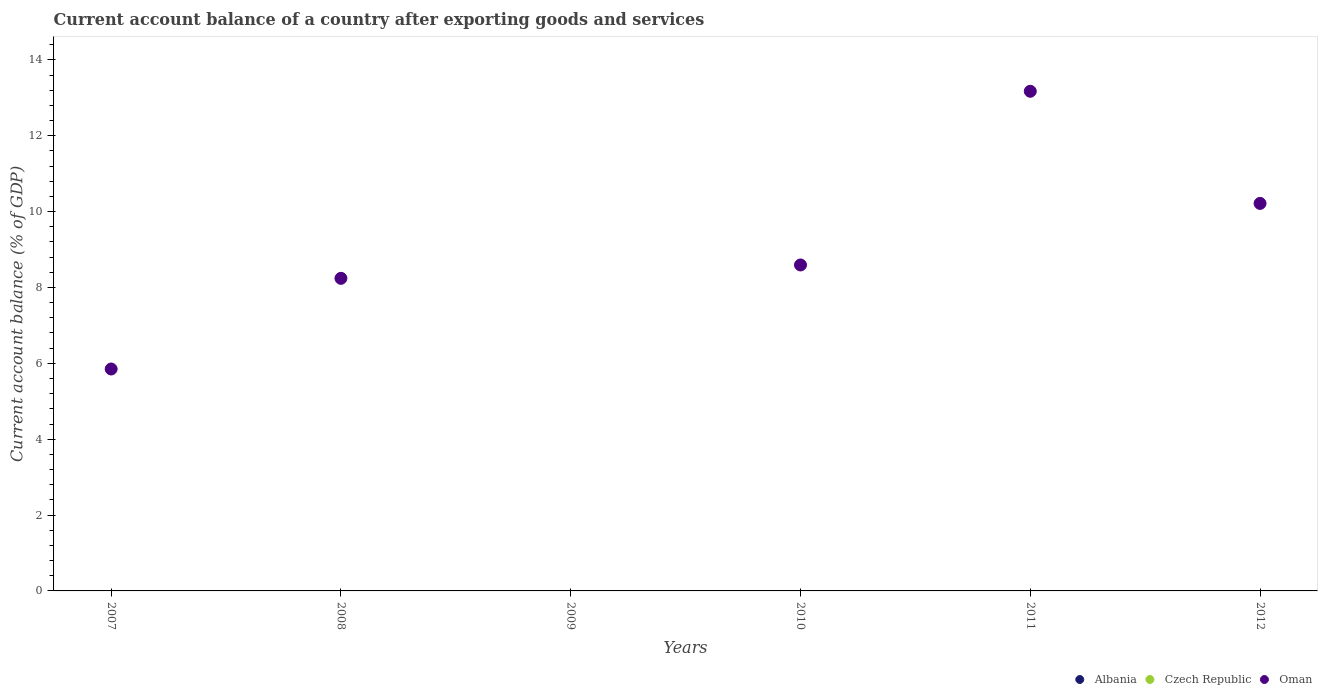How many different coloured dotlines are there?
Ensure brevity in your answer.  1. Is the number of dotlines equal to the number of legend labels?
Ensure brevity in your answer.  No. Across all years, what is the minimum account balance in Albania?
Ensure brevity in your answer.  0. What is the total account balance in Oman in the graph?
Your response must be concise. 46.07. What is the difference between the account balance in Oman in 2010 and that in 2012?
Offer a very short reply. -1.62. What is the difference between the account balance in Oman in 2008 and the account balance in Albania in 2007?
Offer a very short reply. 8.24. What is the average account balance in Oman per year?
Your answer should be compact. 7.68. What is the ratio of the account balance in Oman in 2010 to that in 2011?
Provide a short and direct response. 0.65. What is the difference between the highest and the second highest account balance in Oman?
Provide a short and direct response. 2.96. What is the difference between the highest and the lowest account balance in Oman?
Make the answer very short. 13.17. Is the sum of the account balance in Oman in 2011 and 2012 greater than the maximum account balance in Albania across all years?
Make the answer very short. Yes. Is it the case that in every year, the sum of the account balance in Czech Republic and account balance in Oman  is greater than the account balance in Albania?
Provide a succinct answer. No. Is the account balance in Oman strictly greater than the account balance in Albania over the years?
Offer a terse response. Yes. Is the account balance in Oman strictly less than the account balance in Albania over the years?
Your answer should be very brief. No. How many years are there in the graph?
Offer a very short reply. 6. What is the difference between two consecutive major ticks on the Y-axis?
Provide a short and direct response. 2. Are the values on the major ticks of Y-axis written in scientific E-notation?
Keep it short and to the point. No. Where does the legend appear in the graph?
Your answer should be very brief. Bottom right. How are the legend labels stacked?
Ensure brevity in your answer.  Horizontal. What is the title of the graph?
Give a very brief answer. Current account balance of a country after exporting goods and services. Does "Middle East & North Africa (developing only)" appear as one of the legend labels in the graph?
Provide a short and direct response. No. What is the label or title of the Y-axis?
Ensure brevity in your answer.  Current account balance (% of GDP). What is the Current account balance (% of GDP) of Albania in 2007?
Keep it short and to the point. 0. What is the Current account balance (% of GDP) in Oman in 2007?
Your response must be concise. 5.85. What is the Current account balance (% of GDP) of Albania in 2008?
Ensure brevity in your answer.  0. What is the Current account balance (% of GDP) of Oman in 2008?
Provide a succinct answer. 8.24. What is the Current account balance (% of GDP) of Oman in 2009?
Your answer should be very brief. 0. What is the Current account balance (% of GDP) of Oman in 2010?
Offer a terse response. 8.59. What is the Current account balance (% of GDP) in Albania in 2011?
Your answer should be compact. 0. What is the Current account balance (% of GDP) in Czech Republic in 2011?
Provide a succinct answer. 0. What is the Current account balance (% of GDP) in Oman in 2011?
Your answer should be compact. 13.17. What is the Current account balance (% of GDP) in Oman in 2012?
Offer a very short reply. 10.22. Across all years, what is the maximum Current account balance (% of GDP) of Oman?
Make the answer very short. 13.17. Across all years, what is the minimum Current account balance (% of GDP) of Oman?
Offer a very short reply. 0. What is the total Current account balance (% of GDP) of Oman in the graph?
Provide a short and direct response. 46.07. What is the difference between the Current account balance (% of GDP) in Oman in 2007 and that in 2008?
Your answer should be compact. -2.39. What is the difference between the Current account balance (% of GDP) of Oman in 2007 and that in 2010?
Your answer should be very brief. -2.74. What is the difference between the Current account balance (% of GDP) in Oman in 2007 and that in 2011?
Provide a short and direct response. -7.32. What is the difference between the Current account balance (% of GDP) in Oman in 2007 and that in 2012?
Ensure brevity in your answer.  -4.37. What is the difference between the Current account balance (% of GDP) of Oman in 2008 and that in 2010?
Ensure brevity in your answer.  -0.35. What is the difference between the Current account balance (% of GDP) of Oman in 2008 and that in 2011?
Your answer should be very brief. -4.93. What is the difference between the Current account balance (% of GDP) in Oman in 2008 and that in 2012?
Offer a terse response. -1.97. What is the difference between the Current account balance (% of GDP) in Oman in 2010 and that in 2011?
Your answer should be very brief. -4.58. What is the difference between the Current account balance (% of GDP) in Oman in 2010 and that in 2012?
Provide a short and direct response. -1.62. What is the difference between the Current account balance (% of GDP) in Oman in 2011 and that in 2012?
Your answer should be compact. 2.96. What is the average Current account balance (% of GDP) of Albania per year?
Offer a terse response. 0. What is the average Current account balance (% of GDP) in Czech Republic per year?
Make the answer very short. 0. What is the average Current account balance (% of GDP) in Oman per year?
Your answer should be very brief. 7.68. What is the ratio of the Current account balance (% of GDP) of Oman in 2007 to that in 2008?
Provide a short and direct response. 0.71. What is the ratio of the Current account balance (% of GDP) of Oman in 2007 to that in 2010?
Provide a short and direct response. 0.68. What is the ratio of the Current account balance (% of GDP) of Oman in 2007 to that in 2011?
Offer a very short reply. 0.44. What is the ratio of the Current account balance (% of GDP) in Oman in 2007 to that in 2012?
Offer a terse response. 0.57. What is the ratio of the Current account balance (% of GDP) in Oman in 2008 to that in 2010?
Keep it short and to the point. 0.96. What is the ratio of the Current account balance (% of GDP) of Oman in 2008 to that in 2011?
Keep it short and to the point. 0.63. What is the ratio of the Current account balance (% of GDP) in Oman in 2008 to that in 2012?
Your answer should be compact. 0.81. What is the ratio of the Current account balance (% of GDP) of Oman in 2010 to that in 2011?
Your response must be concise. 0.65. What is the ratio of the Current account balance (% of GDP) of Oman in 2010 to that in 2012?
Offer a very short reply. 0.84. What is the ratio of the Current account balance (% of GDP) in Oman in 2011 to that in 2012?
Make the answer very short. 1.29. What is the difference between the highest and the second highest Current account balance (% of GDP) in Oman?
Your answer should be compact. 2.96. What is the difference between the highest and the lowest Current account balance (% of GDP) in Oman?
Your answer should be compact. 13.17. 